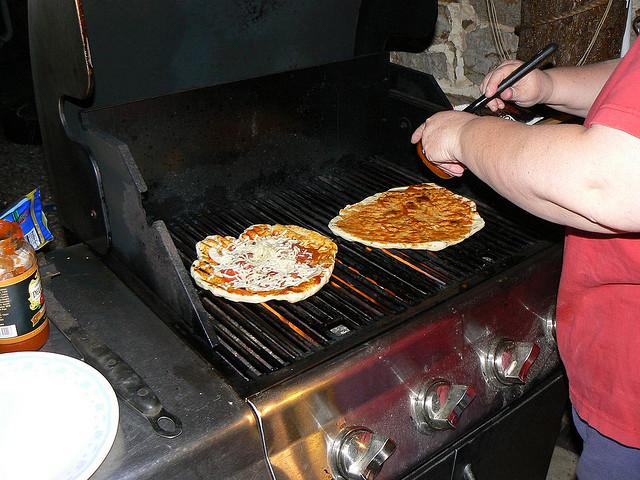What do you think that dish is in the scene?
Keep it brief. Pizza. What is being used to cook?
Write a very short answer. Grill. Do you see a brick wall?
Short answer required. Yes. 